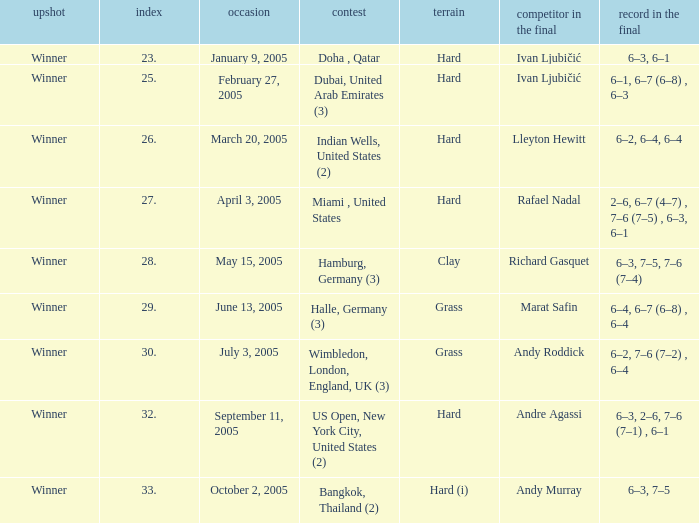In the championship Indian Wells, United States (2), who are the opponents in the final? Lleyton Hewitt. 